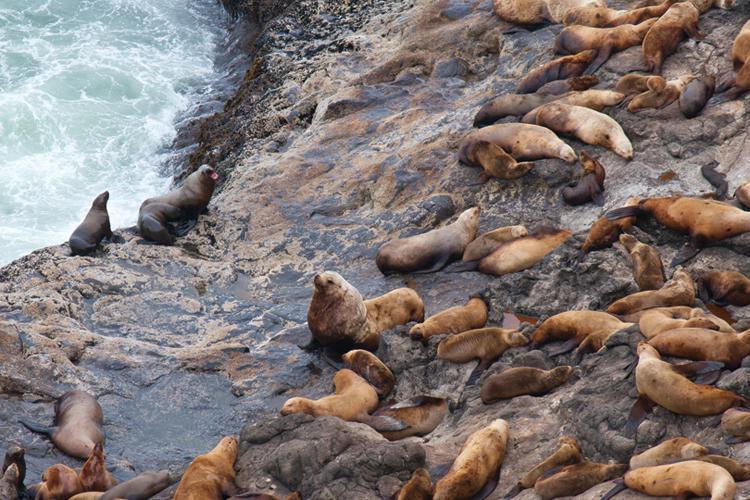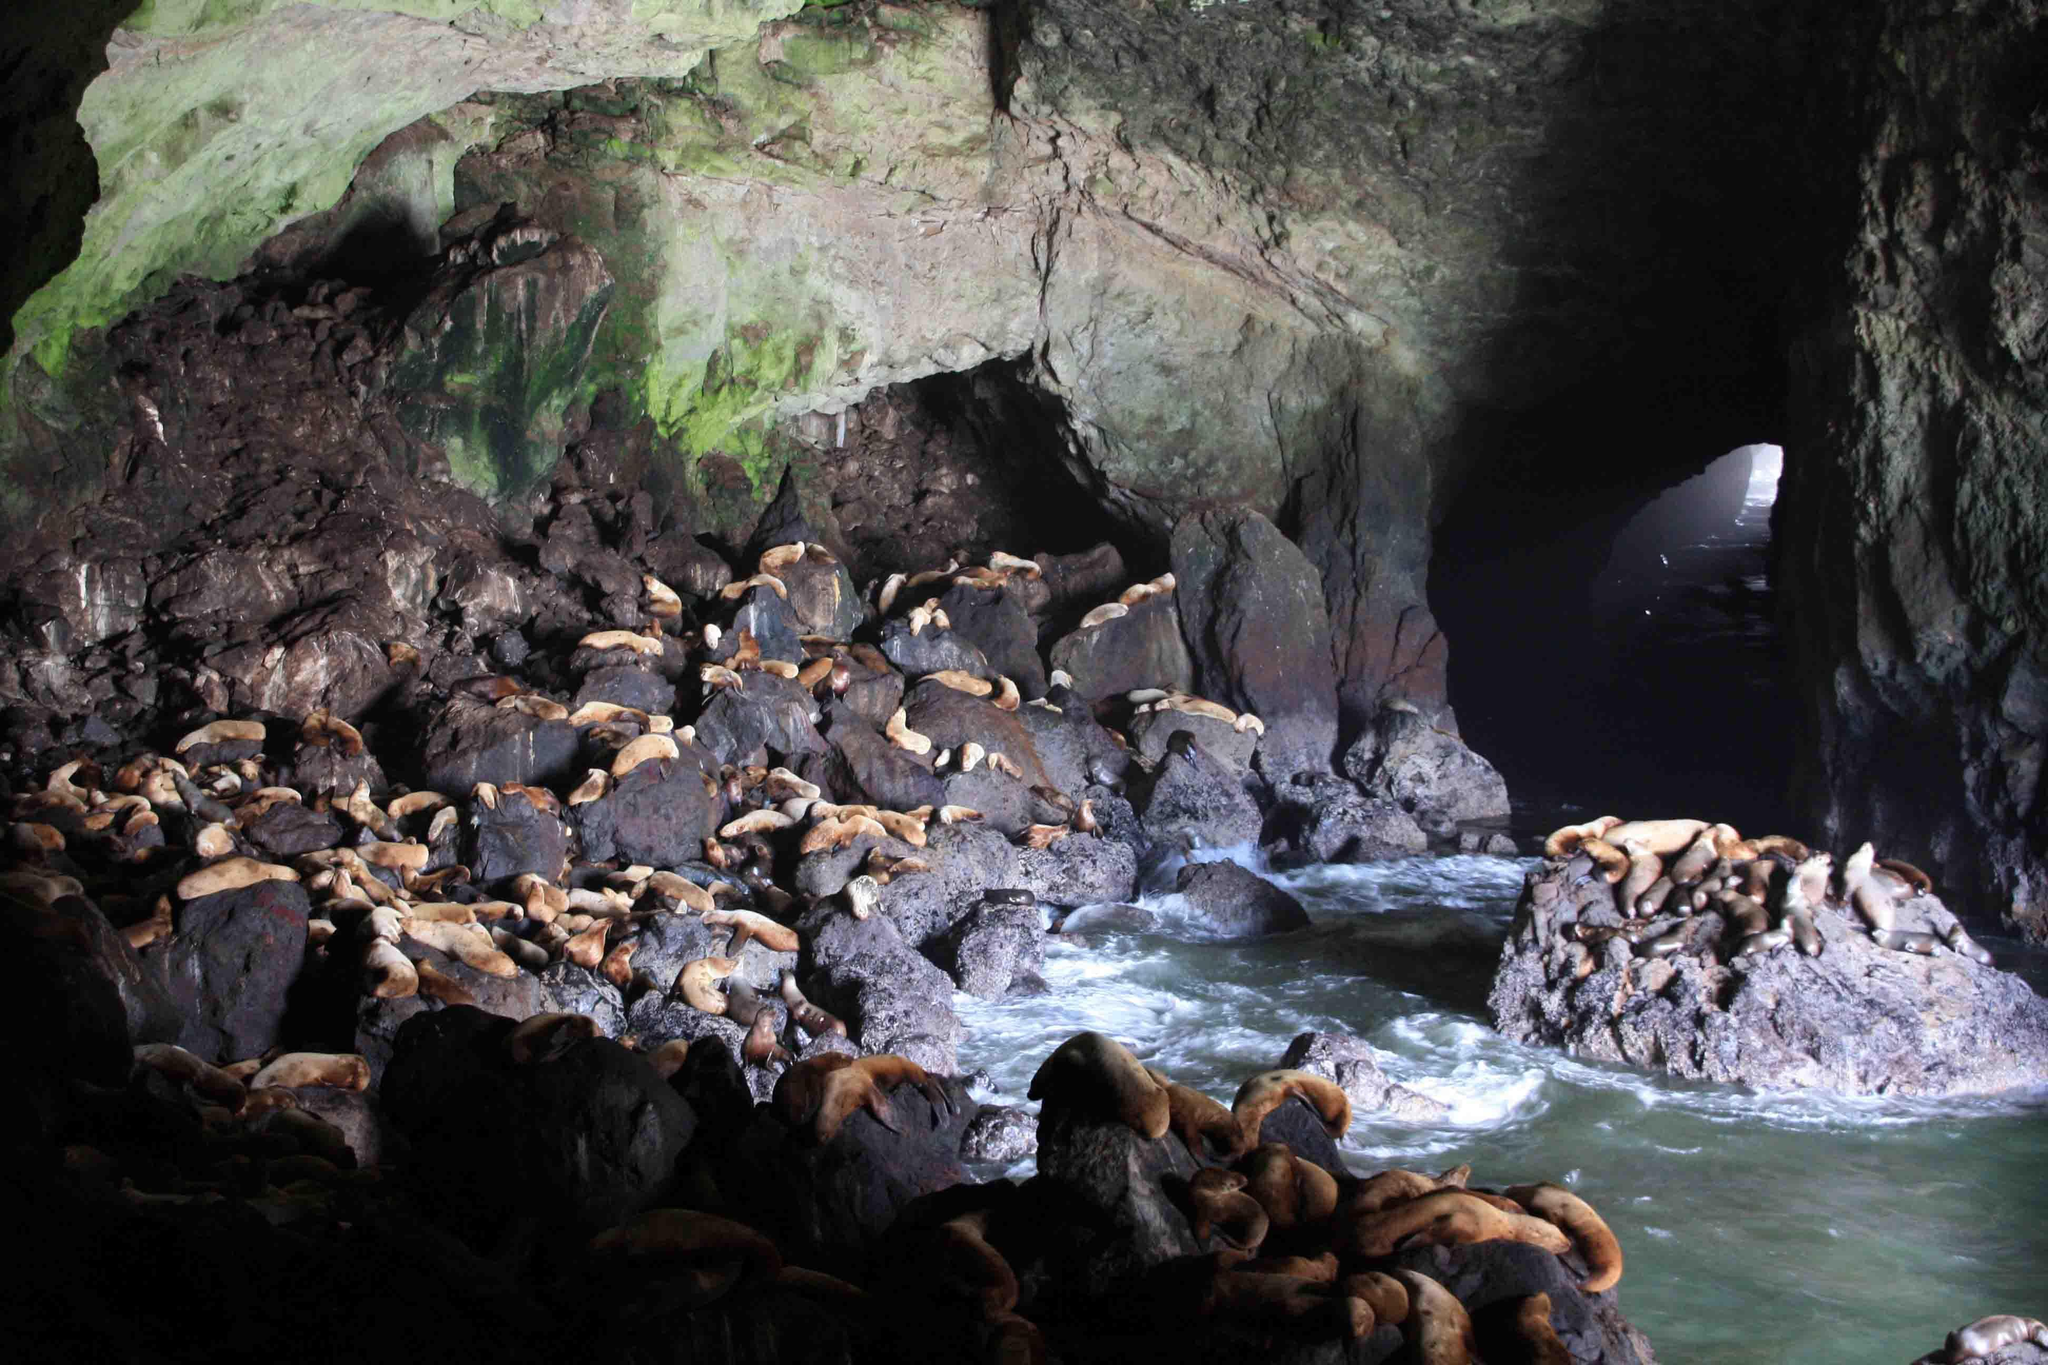The first image is the image on the left, the second image is the image on the right. Analyze the images presented: Is the assertion "light spills through a small hole in the cave wall in the image on the right." valid? Answer yes or no. Yes. 